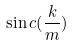Convert formula to latex. <formula><loc_0><loc_0><loc_500><loc_500>\sin c ( \frac { k } { m } )</formula> 